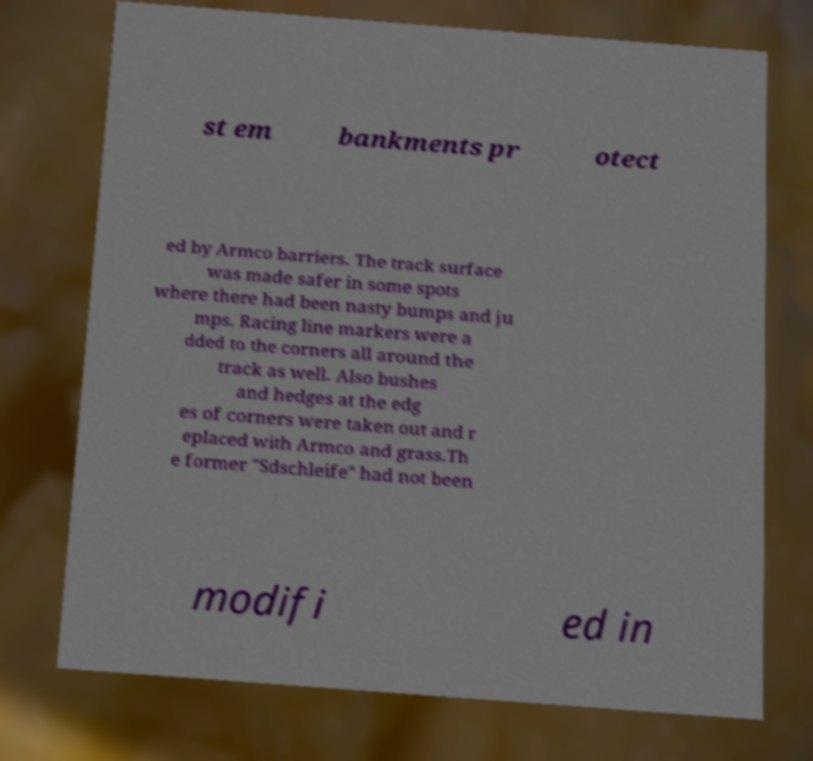What messages or text are displayed in this image? I need them in a readable, typed format. st em bankments pr otect ed by Armco barriers. The track surface was made safer in some spots where there had been nasty bumps and ju mps. Racing line markers were a dded to the corners all around the track as well. Also bushes and hedges at the edg es of corners were taken out and r eplaced with Armco and grass.Th e former "Sdschleife" had not been modifi ed in 